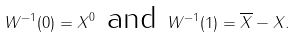<formula> <loc_0><loc_0><loc_500><loc_500>W ^ { - 1 } ( 0 ) = X ^ { 0 } \text { and } W ^ { - 1 } ( 1 ) = \overline { X } - X .</formula> 